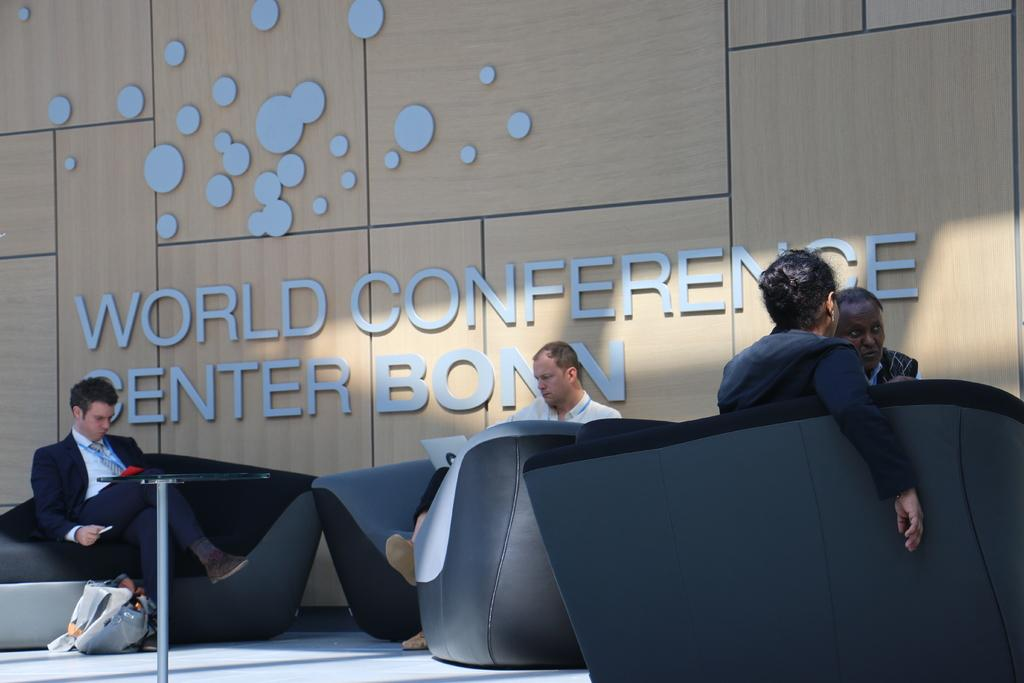What are the people in the image doing? The people in the image are sitting in the sofas. What can be seen in the image besides the people? There is a table in the image. What is visible in the background of the image? There is a wall in the background of the image. What is written on the wall in the image? The wall has the text "World Conference Center Bonn" written on it. How does the theory of relativity apply to the image? The theory of relativity is a scientific concept and cannot be applied to the image, as it is a photograph of people sitting in a room. 